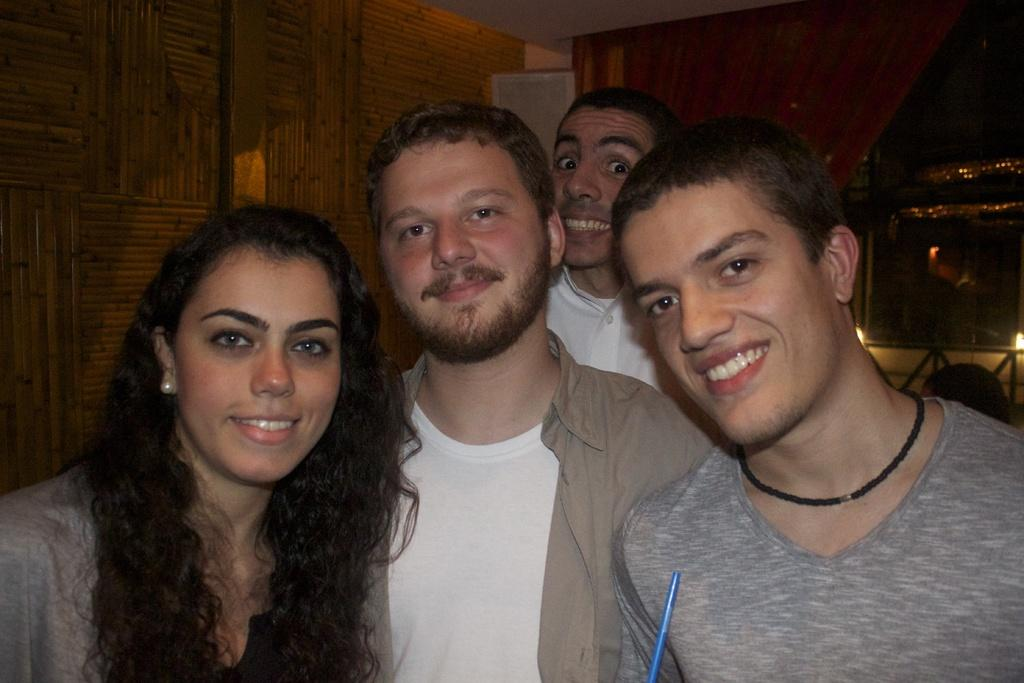How many people are in the image? There is a group of people in the image. What is the facial expression of the people in the image? The people are smiling. What can be seen in the background of the image? There is a wall and objects visible in the background of the image. How many frogs are sitting on the person's shoulder in the image? There are no frogs present in the image, and no person is mentioned in the provided facts. 